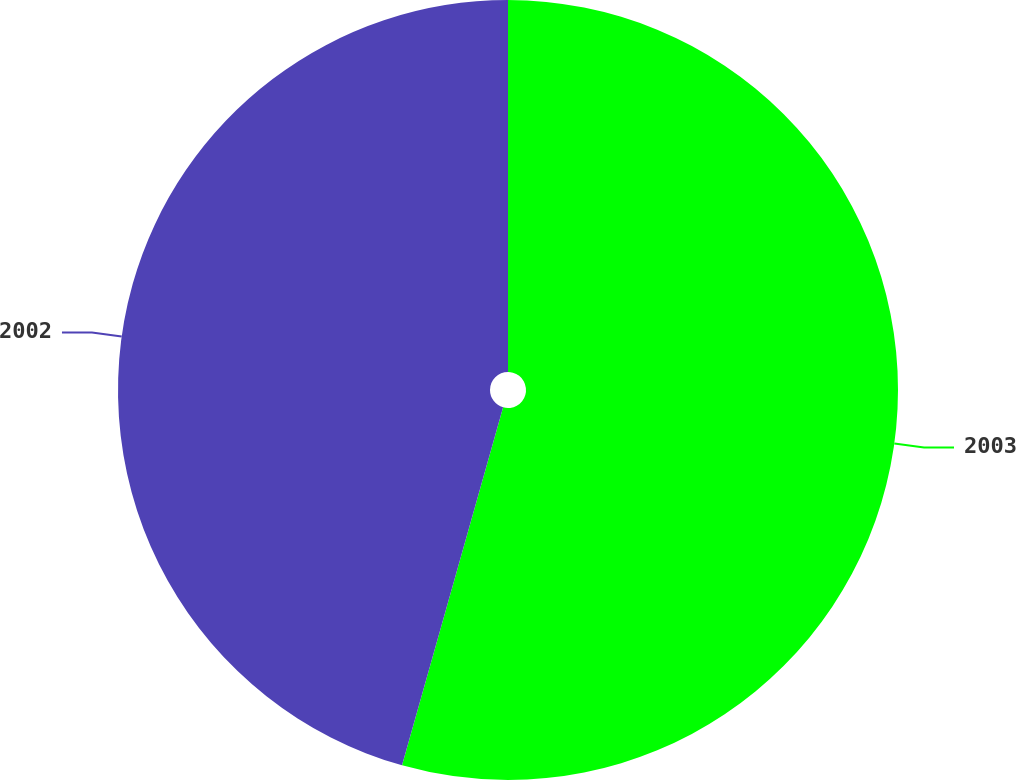Convert chart to OTSL. <chart><loc_0><loc_0><loc_500><loc_500><pie_chart><fcel>2003<fcel>2002<nl><fcel>54.38%<fcel>45.62%<nl></chart> 